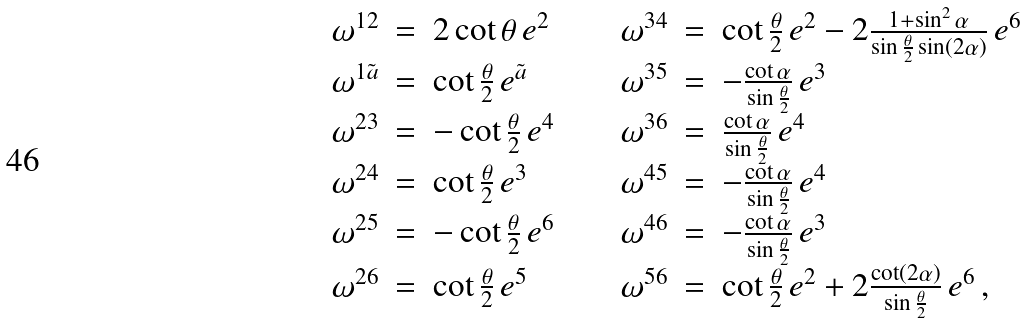<formula> <loc_0><loc_0><loc_500><loc_500>\begin{array} { r c l c r c l } \omega ^ { 1 2 } & = & 2 \cot \theta \, e ^ { 2 } & \quad & \omega ^ { 3 4 } & = & \cot \frac { \theta } { 2 } \, e ^ { 2 } - 2 \frac { 1 + \sin ^ { 2 } \alpha } { \sin \frac { \theta } { 2 } \sin ( 2 \alpha ) } \, e ^ { 6 } \\ \omega ^ { 1 \tilde { a } } & = & \cot \frac { \theta } { 2 } \, e ^ { \tilde { a } } & & \omega ^ { 3 5 } & = & - \frac { \cot \alpha } { \sin \frac { \theta } { 2 } } \, e ^ { 3 } \\ \omega ^ { 2 3 } & = & - \cot \frac { \theta } { 2 } \, e ^ { 4 } & & \omega ^ { 3 6 } & = & \frac { \cot \alpha } { \sin \frac { \theta } { 2 } } \, e ^ { 4 } \\ \omega ^ { 2 4 } & = & \cot \frac { \theta } { 2 } \, e ^ { 3 } & & \omega ^ { 4 5 } & = & - \frac { \cot \alpha } { \sin \frac { \theta } { 2 } } \, e ^ { 4 } \\ \omega ^ { 2 5 } & = & - \cot \frac { \theta } { 2 } \, e ^ { 6 } & & \omega ^ { 4 6 } & = & - \frac { \cot \alpha } { \sin \frac { \theta } { 2 } } \, e ^ { 3 } \\ \omega ^ { 2 6 } & = & \cot \frac { \theta } { 2 } \, e ^ { 5 } & & \omega ^ { 5 6 } & = & \cot \frac { \theta } { 2 } \, e ^ { 2 } + 2 \frac { \cot ( 2 \alpha ) } { \sin \frac { \theta } { 2 } } \, e ^ { 6 } \, , \end{array}</formula> 